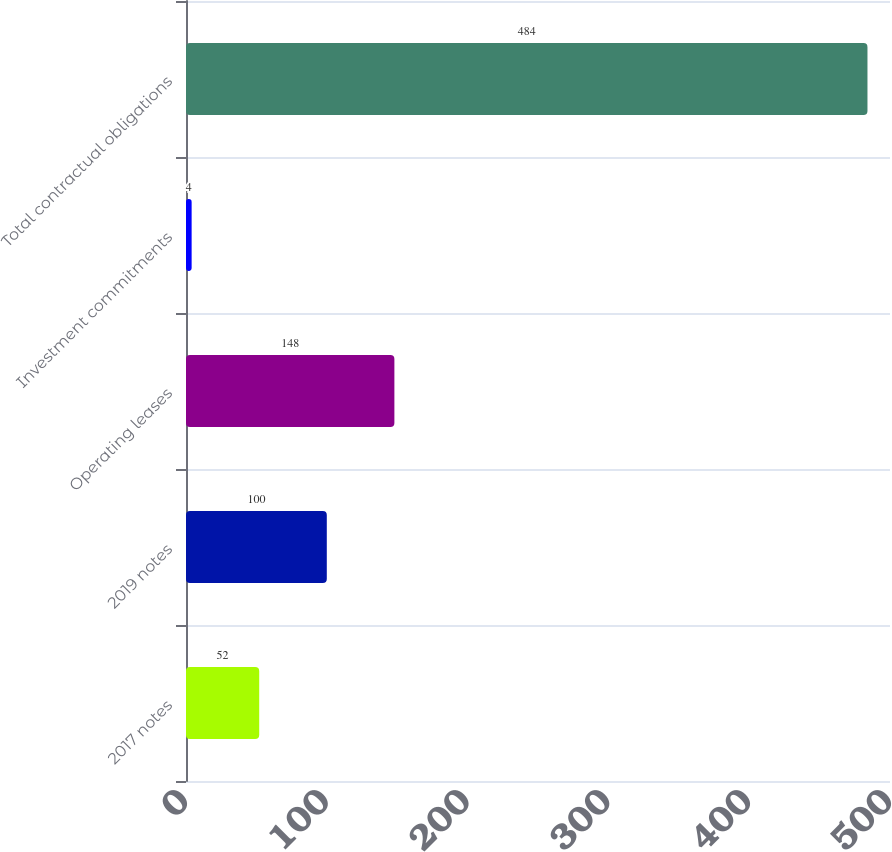<chart> <loc_0><loc_0><loc_500><loc_500><bar_chart><fcel>2017 notes<fcel>2019 notes<fcel>Operating leases<fcel>Investment commitments<fcel>Total contractual obligations<nl><fcel>52<fcel>100<fcel>148<fcel>4<fcel>484<nl></chart> 